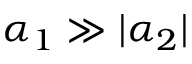<formula> <loc_0><loc_0><loc_500><loc_500>\alpha _ { 1 } \gg | \alpha _ { 2 } |</formula> 